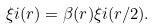Convert formula to latex. <formula><loc_0><loc_0><loc_500><loc_500>\xi i ( r ) = \beta ( r ) \xi i ( r / 2 ) .</formula> 